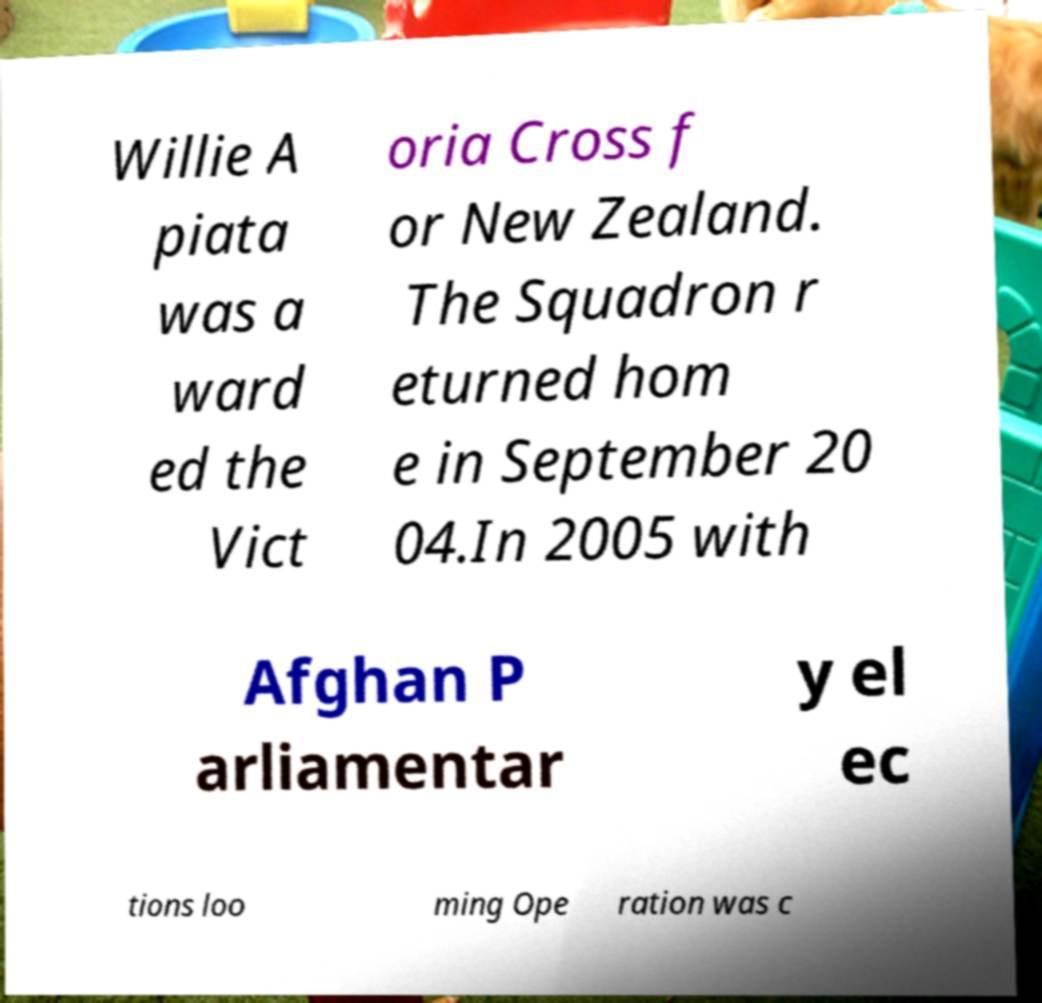I need the written content from this picture converted into text. Can you do that? Willie A piata was a ward ed the Vict oria Cross f or New Zealand. The Squadron r eturned hom e in September 20 04.In 2005 with Afghan P arliamentar y el ec tions loo ming Ope ration was c 